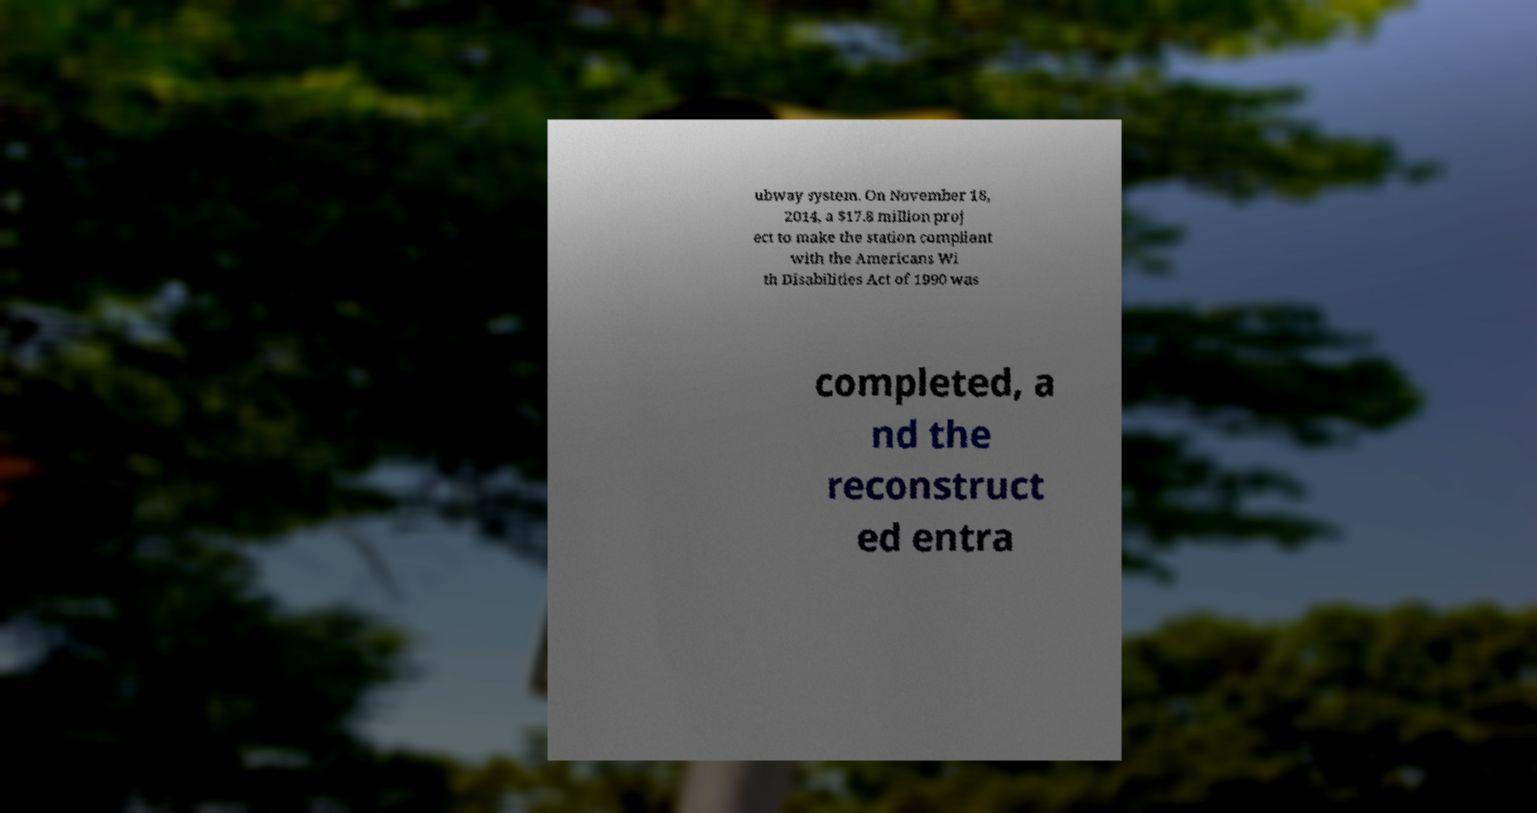For documentation purposes, I need the text within this image transcribed. Could you provide that? ubway system. On November 18, 2014, a $17.8 million proj ect to make the station compliant with the Americans Wi th Disabilities Act of 1990 was completed, a nd the reconstruct ed entra 